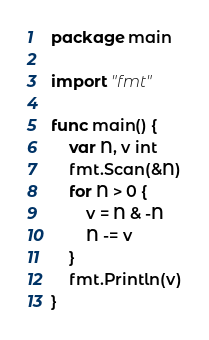Convert code to text. <code><loc_0><loc_0><loc_500><loc_500><_Go_>package main

import "fmt"

func main() {
	var N, v int
	fmt.Scan(&N)
	for N > 0 {
		v = N & -N
		N -= v
	}
	fmt.Println(v)
}
</code> 